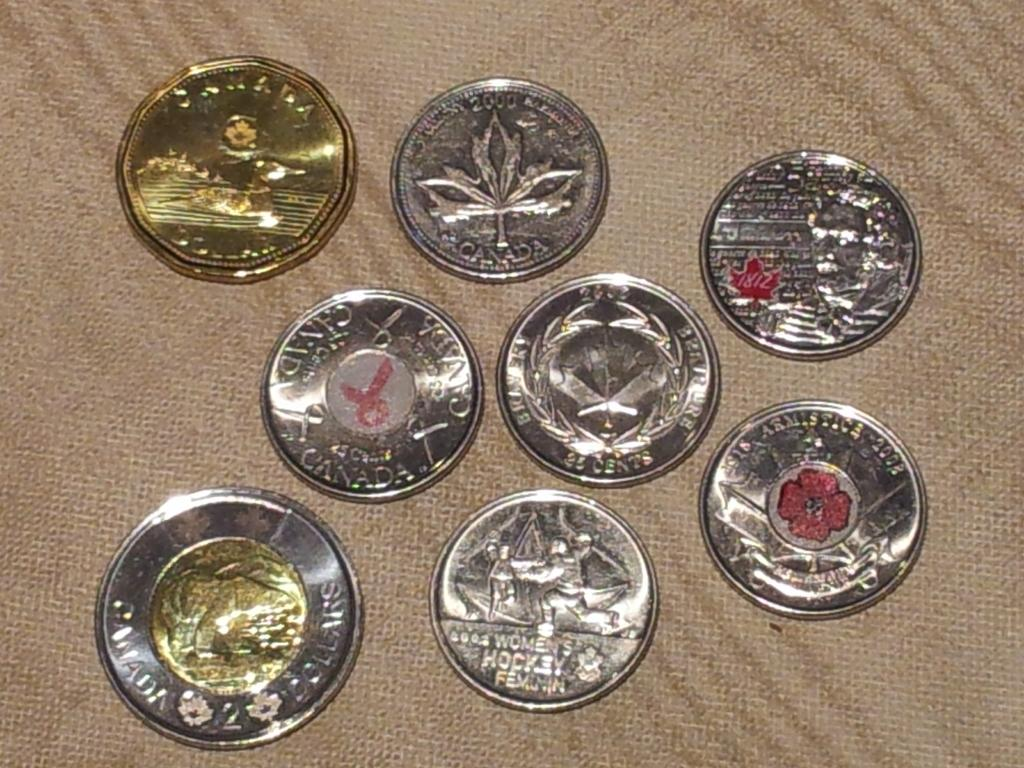<image>
Describe the image concisely. Various shiny Canadian coins are arranged on a light brown cloth. 